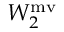<formula> <loc_0><loc_0><loc_500><loc_500>W _ { 2 } ^ { m v }</formula> 